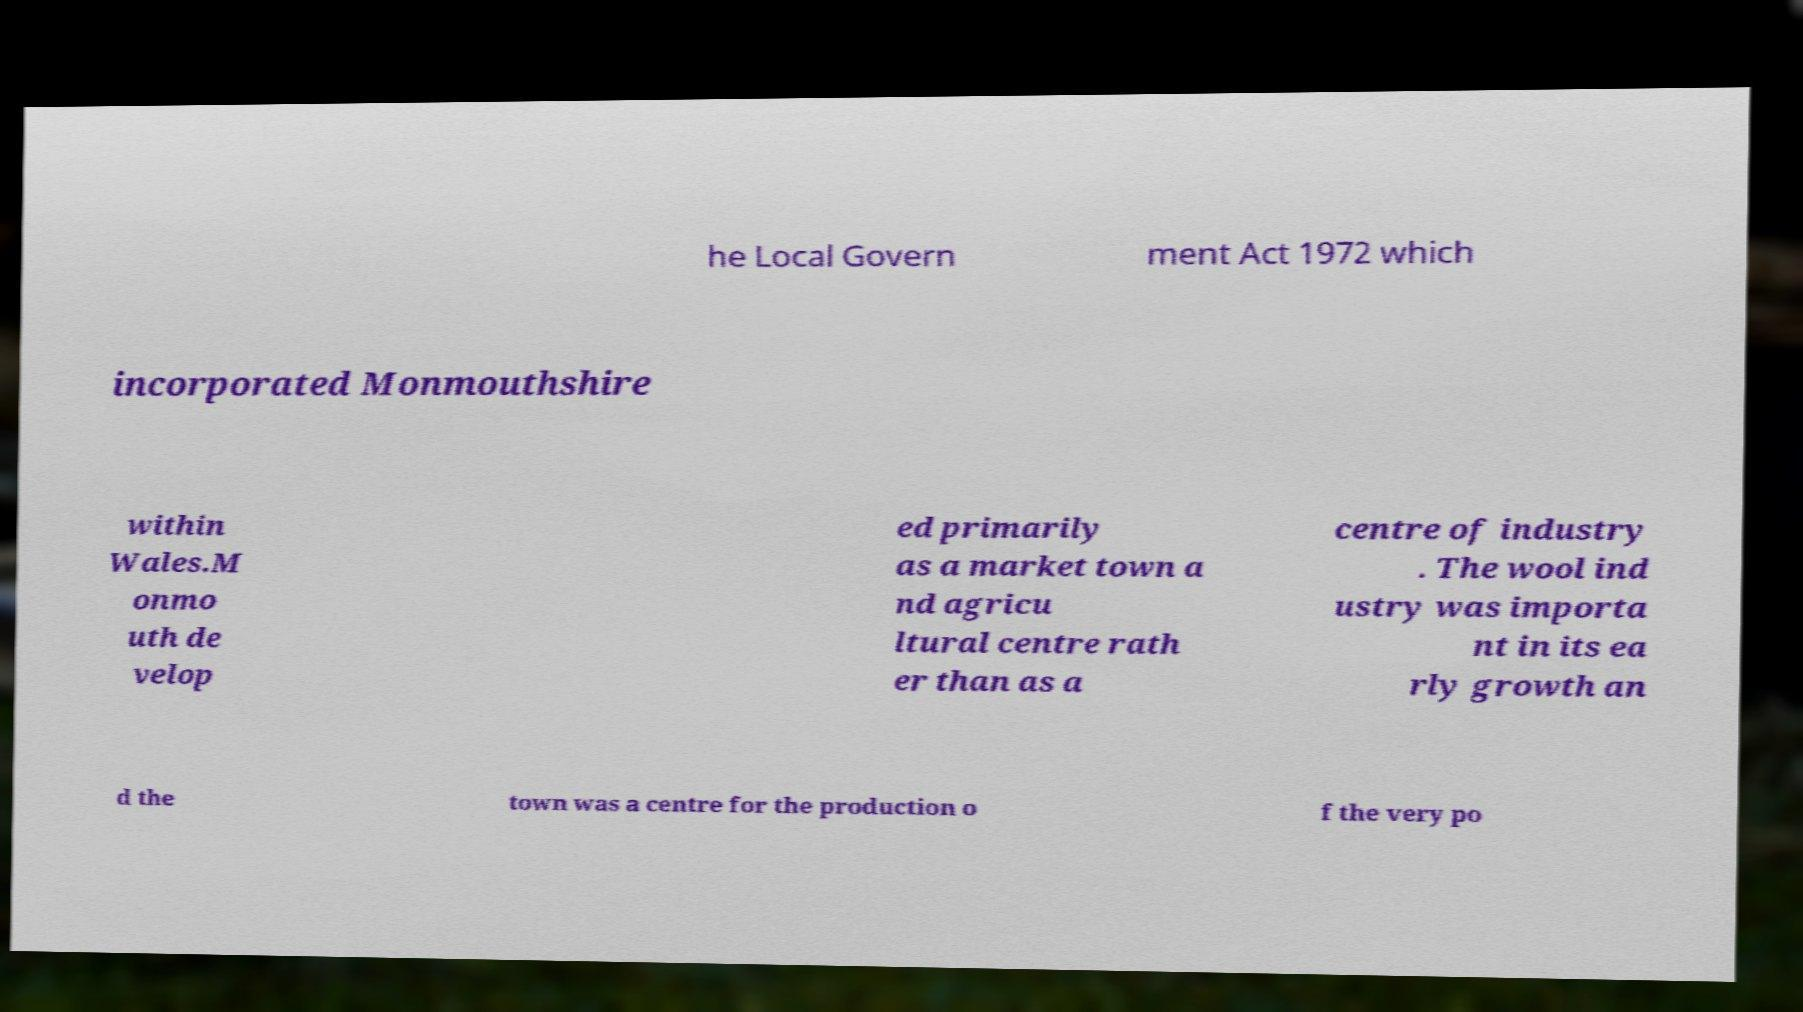Could you extract and type out the text from this image? he Local Govern ment Act 1972 which incorporated Monmouthshire within Wales.M onmo uth de velop ed primarily as a market town a nd agricu ltural centre rath er than as a centre of industry . The wool ind ustry was importa nt in its ea rly growth an d the town was a centre for the production o f the very po 